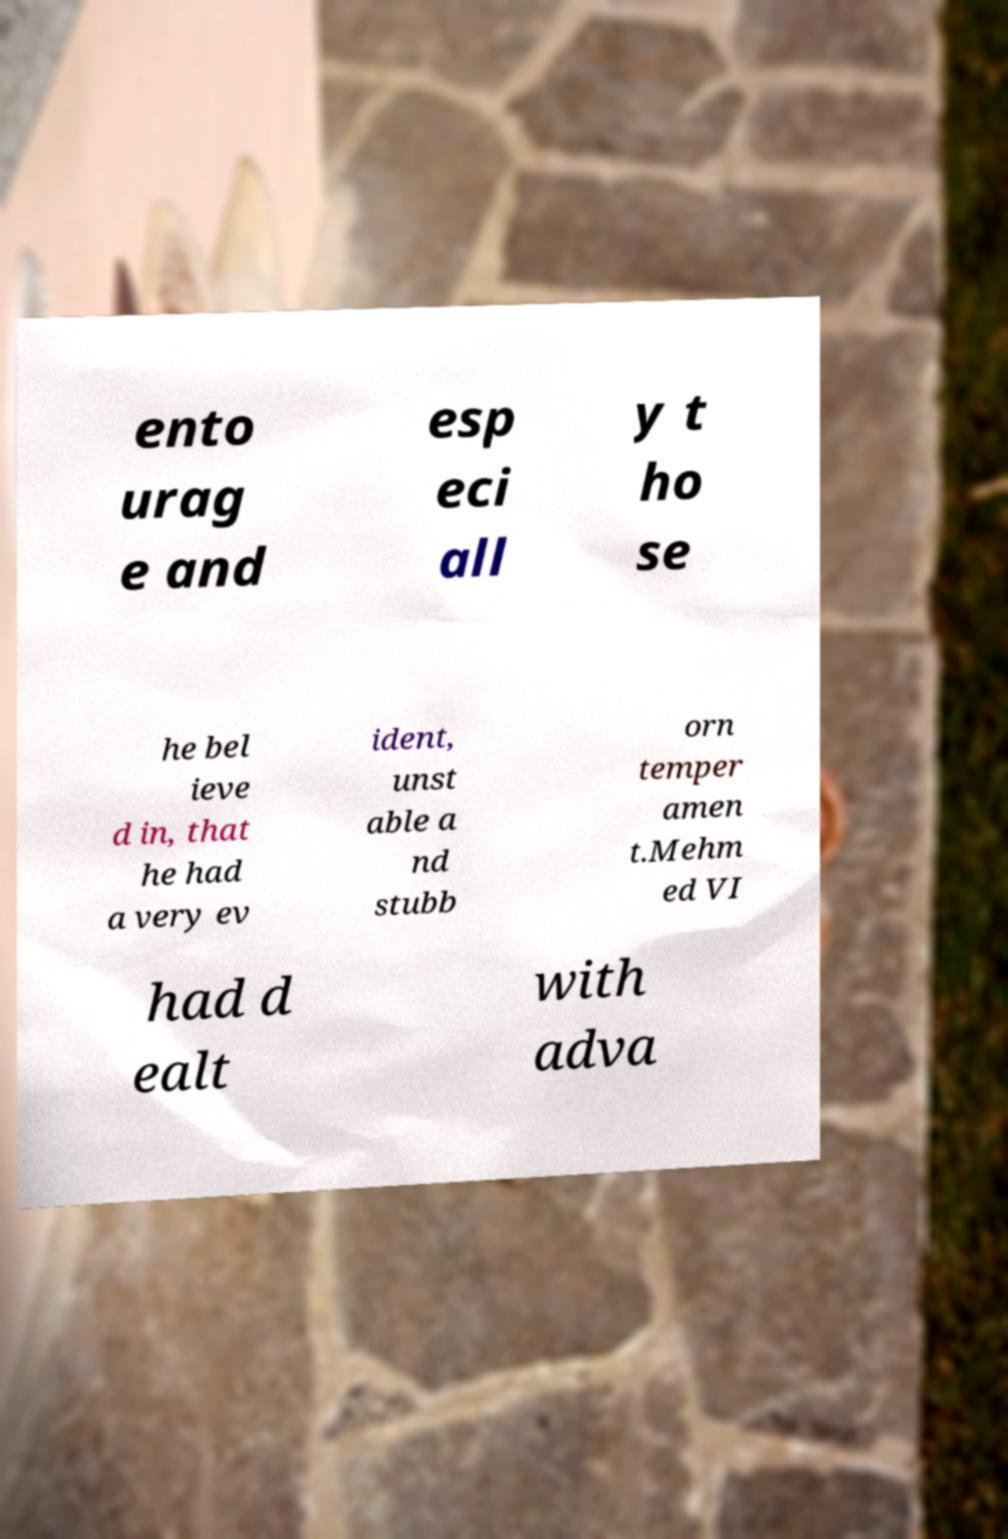Please identify and transcribe the text found in this image. ento urag e and esp eci all y t ho se he bel ieve d in, that he had a very ev ident, unst able a nd stubb orn temper amen t.Mehm ed VI had d ealt with adva 